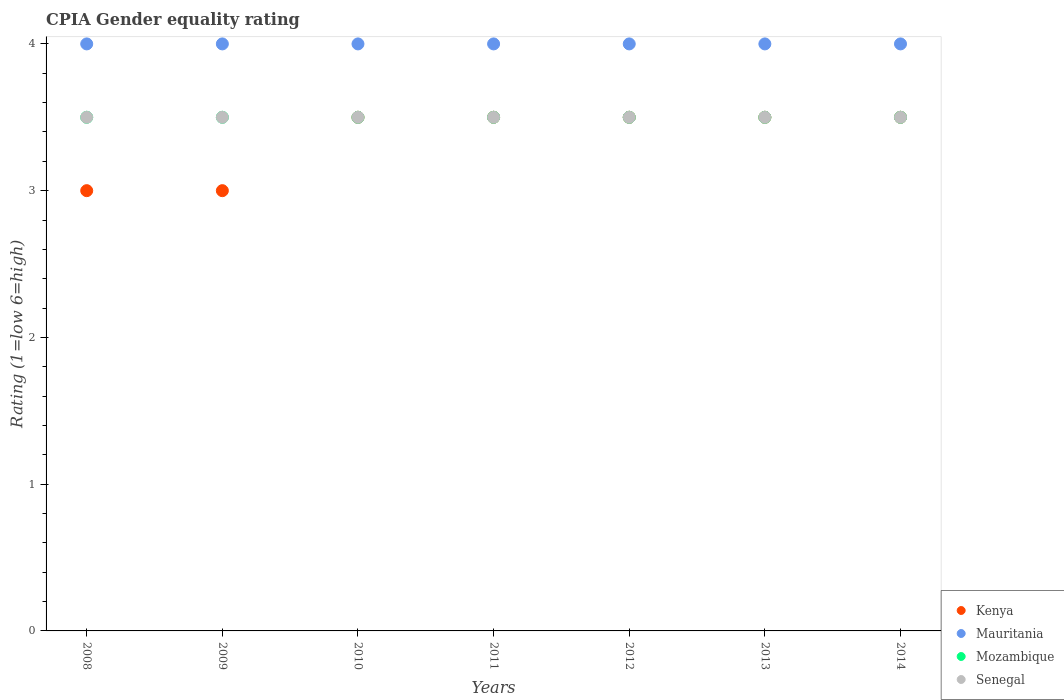How many different coloured dotlines are there?
Your answer should be compact. 4. Is the number of dotlines equal to the number of legend labels?
Offer a very short reply. Yes. What is the CPIA rating in Senegal in 2013?
Give a very brief answer. 3.5. Across all years, what is the minimum CPIA rating in Mozambique?
Offer a terse response. 3.5. In the year 2011, what is the difference between the CPIA rating in Mauritania and CPIA rating in Mozambique?
Offer a terse response. 0.5. In how many years, is the CPIA rating in Senegal greater than 0.2?
Offer a terse response. 7. Is the difference between the CPIA rating in Mauritania in 2010 and 2013 greater than the difference between the CPIA rating in Mozambique in 2010 and 2013?
Give a very brief answer. No. What is the difference between the highest and the lowest CPIA rating in Kenya?
Your answer should be very brief. 0.5. In how many years, is the CPIA rating in Mauritania greater than the average CPIA rating in Mauritania taken over all years?
Your answer should be compact. 0. Is it the case that in every year, the sum of the CPIA rating in Mozambique and CPIA rating in Senegal  is greater than the sum of CPIA rating in Mauritania and CPIA rating in Kenya?
Your answer should be very brief. No. Is the CPIA rating in Kenya strictly greater than the CPIA rating in Mozambique over the years?
Make the answer very short. No. Is the CPIA rating in Mauritania strictly less than the CPIA rating in Kenya over the years?
Ensure brevity in your answer.  No. How many dotlines are there?
Provide a short and direct response. 4. How many years are there in the graph?
Provide a short and direct response. 7. Does the graph contain any zero values?
Offer a very short reply. No. Where does the legend appear in the graph?
Offer a terse response. Bottom right. How many legend labels are there?
Keep it short and to the point. 4. How are the legend labels stacked?
Provide a short and direct response. Vertical. What is the title of the graph?
Offer a very short reply. CPIA Gender equality rating. Does "Palau" appear as one of the legend labels in the graph?
Ensure brevity in your answer.  No. What is the label or title of the X-axis?
Offer a terse response. Years. What is the label or title of the Y-axis?
Your response must be concise. Rating (1=low 6=high). What is the Rating (1=low 6=high) of Kenya in 2008?
Keep it short and to the point. 3. What is the Rating (1=low 6=high) of Senegal in 2008?
Make the answer very short. 3.5. What is the Rating (1=low 6=high) in Mauritania in 2009?
Offer a very short reply. 4. What is the Rating (1=low 6=high) in Mozambique in 2009?
Your answer should be very brief. 3.5. What is the Rating (1=low 6=high) of Senegal in 2009?
Provide a succinct answer. 3.5. What is the Rating (1=low 6=high) of Mauritania in 2010?
Keep it short and to the point. 4. What is the Rating (1=low 6=high) of Mozambique in 2010?
Ensure brevity in your answer.  3.5. What is the Rating (1=low 6=high) in Mauritania in 2011?
Your response must be concise. 4. What is the Rating (1=low 6=high) of Mozambique in 2011?
Ensure brevity in your answer.  3.5. What is the Rating (1=low 6=high) in Kenya in 2012?
Offer a terse response. 3.5. What is the Rating (1=low 6=high) in Mauritania in 2012?
Give a very brief answer. 4. What is the Rating (1=low 6=high) in Mozambique in 2012?
Your answer should be very brief. 3.5. What is the Rating (1=low 6=high) in Senegal in 2012?
Provide a succinct answer. 3.5. What is the Rating (1=low 6=high) in Mauritania in 2013?
Your answer should be compact. 4. What is the Rating (1=low 6=high) of Mauritania in 2014?
Provide a short and direct response. 4. What is the Rating (1=low 6=high) of Mozambique in 2014?
Provide a short and direct response. 3.5. What is the Rating (1=low 6=high) of Senegal in 2014?
Offer a terse response. 3.5. Across all years, what is the maximum Rating (1=low 6=high) of Kenya?
Provide a succinct answer. 3.5. Across all years, what is the maximum Rating (1=low 6=high) in Mauritania?
Keep it short and to the point. 4. Across all years, what is the minimum Rating (1=low 6=high) in Mauritania?
Your response must be concise. 4. Across all years, what is the minimum Rating (1=low 6=high) of Mozambique?
Your answer should be very brief. 3.5. What is the total Rating (1=low 6=high) of Kenya in the graph?
Ensure brevity in your answer.  23.5. What is the total Rating (1=low 6=high) of Mauritania in the graph?
Make the answer very short. 28. What is the total Rating (1=low 6=high) of Mozambique in the graph?
Keep it short and to the point. 24.5. What is the difference between the Rating (1=low 6=high) of Kenya in 2008 and that in 2009?
Your response must be concise. 0. What is the difference between the Rating (1=low 6=high) of Mauritania in 2008 and that in 2009?
Offer a very short reply. 0. What is the difference between the Rating (1=low 6=high) of Senegal in 2008 and that in 2009?
Make the answer very short. 0. What is the difference between the Rating (1=low 6=high) of Kenya in 2008 and that in 2010?
Give a very brief answer. -0.5. What is the difference between the Rating (1=low 6=high) in Mauritania in 2008 and that in 2010?
Provide a succinct answer. 0. What is the difference between the Rating (1=low 6=high) of Senegal in 2008 and that in 2010?
Offer a terse response. 0. What is the difference between the Rating (1=low 6=high) of Kenya in 2008 and that in 2011?
Your answer should be compact. -0.5. What is the difference between the Rating (1=low 6=high) of Mauritania in 2008 and that in 2011?
Offer a terse response. 0. What is the difference between the Rating (1=low 6=high) of Kenya in 2008 and that in 2012?
Offer a very short reply. -0.5. What is the difference between the Rating (1=low 6=high) in Senegal in 2008 and that in 2012?
Provide a short and direct response. 0. What is the difference between the Rating (1=low 6=high) of Mauritania in 2008 and that in 2013?
Keep it short and to the point. 0. What is the difference between the Rating (1=low 6=high) in Mozambique in 2008 and that in 2013?
Make the answer very short. 0. What is the difference between the Rating (1=low 6=high) in Kenya in 2008 and that in 2014?
Your answer should be compact. -0.5. What is the difference between the Rating (1=low 6=high) of Mauritania in 2008 and that in 2014?
Give a very brief answer. 0. What is the difference between the Rating (1=low 6=high) of Mozambique in 2008 and that in 2014?
Provide a short and direct response. 0. What is the difference between the Rating (1=low 6=high) in Senegal in 2008 and that in 2014?
Keep it short and to the point. 0. What is the difference between the Rating (1=low 6=high) of Kenya in 2009 and that in 2010?
Your response must be concise. -0.5. What is the difference between the Rating (1=low 6=high) in Mauritania in 2009 and that in 2010?
Provide a succinct answer. 0. What is the difference between the Rating (1=low 6=high) of Kenya in 2009 and that in 2011?
Your response must be concise. -0.5. What is the difference between the Rating (1=low 6=high) in Mozambique in 2009 and that in 2011?
Offer a very short reply. 0. What is the difference between the Rating (1=low 6=high) in Senegal in 2009 and that in 2011?
Your answer should be compact. 0. What is the difference between the Rating (1=low 6=high) of Mauritania in 2009 and that in 2012?
Make the answer very short. 0. What is the difference between the Rating (1=low 6=high) in Mozambique in 2009 and that in 2012?
Give a very brief answer. 0. What is the difference between the Rating (1=low 6=high) in Senegal in 2009 and that in 2012?
Give a very brief answer. 0. What is the difference between the Rating (1=low 6=high) in Mauritania in 2009 and that in 2013?
Offer a terse response. 0. What is the difference between the Rating (1=low 6=high) in Mauritania in 2009 and that in 2014?
Your answer should be compact. 0. What is the difference between the Rating (1=low 6=high) in Senegal in 2009 and that in 2014?
Make the answer very short. 0. What is the difference between the Rating (1=low 6=high) of Kenya in 2010 and that in 2011?
Make the answer very short. 0. What is the difference between the Rating (1=low 6=high) in Mozambique in 2010 and that in 2011?
Provide a short and direct response. 0. What is the difference between the Rating (1=low 6=high) in Mauritania in 2010 and that in 2012?
Make the answer very short. 0. What is the difference between the Rating (1=low 6=high) of Mozambique in 2010 and that in 2012?
Your response must be concise. 0. What is the difference between the Rating (1=low 6=high) in Senegal in 2010 and that in 2012?
Keep it short and to the point. 0. What is the difference between the Rating (1=low 6=high) in Kenya in 2010 and that in 2013?
Offer a terse response. 0. What is the difference between the Rating (1=low 6=high) of Mauritania in 2010 and that in 2013?
Ensure brevity in your answer.  0. What is the difference between the Rating (1=low 6=high) in Mozambique in 2010 and that in 2014?
Provide a succinct answer. 0. What is the difference between the Rating (1=low 6=high) in Mozambique in 2011 and that in 2012?
Ensure brevity in your answer.  0. What is the difference between the Rating (1=low 6=high) in Senegal in 2011 and that in 2012?
Keep it short and to the point. 0. What is the difference between the Rating (1=low 6=high) in Kenya in 2011 and that in 2013?
Make the answer very short. 0. What is the difference between the Rating (1=low 6=high) of Mauritania in 2011 and that in 2014?
Offer a very short reply. 0. What is the difference between the Rating (1=low 6=high) of Senegal in 2011 and that in 2014?
Keep it short and to the point. 0. What is the difference between the Rating (1=low 6=high) in Kenya in 2012 and that in 2013?
Offer a terse response. 0. What is the difference between the Rating (1=low 6=high) of Mauritania in 2012 and that in 2013?
Provide a short and direct response. 0. What is the difference between the Rating (1=low 6=high) in Senegal in 2012 and that in 2014?
Provide a succinct answer. 0. What is the difference between the Rating (1=low 6=high) of Mozambique in 2013 and that in 2014?
Offer a very short reply. 0. What is the difference between the Rating (1=low 6=high) in Senegal in 2013 and that in 2014?
Your answer should be compact. 0. What is the difference between the Rating (1=low 6=high) of Kenya in 2008 and the Rating (1=low 6=high) of Mauritania in 2009?
Your response must be concise. -1. What is the difference between the Rating (1=low 6=high) in Mauritania in 2008 and the Rating (1=low 6=high) in Mozambique in 2009?
Offer a terse response. 0.5. What is the difference between the Rating (1=low 6=high) of Mauritania in 2008 and the Rating (1=low 6=high) of Senegal in 2009?
Offer a terse response. 0.5. What is the difference between the Rating (1=low 6=high) in Kenya in 2008 and the Rating (1=low 6=high) in Mozambique in 2010?
Provide a short and direct response. -0.5. What is the difference between the Rating (1=low 6=high) in Mauritania in 2008 and the Rating (1=low 6=high) in Mozambique in 2010?
Give a very brief answer. 0.5. What is the difference between the Rating (1=low 6=high) of Mauritania in 2008 and the Rating (1=low 6=high) of Senegal in 2010?
Provide a short and direct response. 0.5. What is the difference between the Rating (1=low 6=high) in Mozambique in 2008 and the Rating (1=low 6=high) in Senegal in 2010?
Keep it short and to the point. 0. What is the difference between the Rating (1=low 6=high) in Kenya in 2008 and the Rating (1=low 6=high) in Mauritania in 2011?
Provide a succinct answer. -1. What is the difference between the Rating (1=low 6=high) in Kenya in 2008 and the Rating (1=low 6=high) in Mozambique in 2011?
Your answer should be very brief. -0.5. What is the difference between the Rating (1=low 6=high) of Mozambique in 2008 and the Rating (1=low 6=high) of Senegal in 2011?
Ensure brevity in your answer.  0. What is the difference between the Rating (1=low 6=high) of Kenya in 2008 and the Rating (1=low 6=high) of Mauritania in 2012?
Offer a very short reply. -1. What is the difference between the Rating (1=low 6=high) of Kenya in 2008 and the Rating (1=low 6=high) of Mozambique in 2012?
Provide a succinct answer. -0.5. What is the difference between the Rating (1=low 6=high) in Mauritania in 2008 and the Rating (1=low 6=high) in Mozambique in 2012?
Your response must be concise. 0.5. What is the difference between the Rating (1=low 6=high) of Mauritania in 2008 and the Rating (1=low 6=high) of Mozambique in 2013?
Ensure brevity in your answer.  0.5. What is the difference between the Rating (1=low 6=high) in Kenya in 2008 and the Rating (1=low 6=high) in Mozambique in 2014?
Keep it short and to the point. -0.5. What is the difference between the Rating (1=low 6=high) in Kenya in 2008 and the Rating (1=low 6=high) in Senegal in 2014?
Make the answer very short. -0.5. What is the difference between the Rating (1=low 6=high) in Mauritania in 2008 and the Rating (1=low 6=high) in Senegal in 2014?
Make the answer very short. 0.5. What is the difference between the Rating (1=low 6=high) in Mozambique in 2008 and the Rating (1=low 6=high) in Senegal in 2014?
Your answer should be compact. 0. What is the difference between the Rating (1=low 6=high) in Kenya in 2009 and the Rating (1=low 6=high) in Mauritania in 2010?
Ensure brevity in your answer.  -1. What is the difference between the Rating (1=low 6=high) in Mauritania in 2009 and the Rating (1=low 6=high) in Mozambique in 2010?
Give a very brief answer. 0.5. What is the difference between the Rating (1=low 6=high) of Kenya in 2009 and the Rating (1=low 6=high) of Mauritania in 2011?
Your answer should be very brief. -1. What is the difference between the Rating (1=low 6=high) in Kenya in 2009 and the Rating (1=low 6=high) in Senegal in 2011?
Keep it short and to the point. -0.5. What is the difference between the Rating (1=low 6=high) in Mauritania in 2009 and the Rating (1=low 6=high) in Senegal in 2011?
Your answer should be compact. 0.5. What is the difference between the Rating (1=low 6=high) in Mozambique in 2009 and the Rating (1=low 6=high) in Senegal in 2011?
Your answer should be very brief. 0. What is the difference between the Rating (1=low 6=high) of Kenya in 2009 and the Rating (1=low 6=high) of Mozambique in 2012?
Your answer should be very brief. -0.5. What is the difference between the Rating (1=low 6=high) of Kenya in 2009 and the Rating (1=low 6=high) of Senegal in 2012?
Your response must be concise. -0.5. What is the difference between the Rating (1=low 6=high) of Mauritania in 2009 and the Rating (1=low 6=high) of Mozambique in 2012?
Your response must be concise. 0.5. What is the difference between the Rating (1=low 6=high) of Mozambique in 2009 and the Rating (1=low 6=high) of Senegal in 2012?
Your response must be concise. 0. What is the difference between the Rating (1=low 6=high) of Kenya in 2009 and the Rating (1=low 6=high) of Mauritania in 2013?
Your answer should be compact. -1. What is the difference between the Rating (1=low 6=high) in Kenya in 2009 and the Rating (1=low 6=high) in Mozambique in 2013?
Your answer should be compact. -0.5. What is the difference between the Rating (1=low 6=high) of Mauritania in 2009 and the Rating (1=low 6=high) of Mozambique in 2013?
Make the answer very short. 0.5. What is the difference between the Rating (1=low 6=high) of Mauritania in 2009 and the Rating (1=low 6=high) of Senegal in 2013?
Your answer should be very brief. 0.5. What is the difference between the Rating (1=low 6=high) in Mozambique in 2009 and the Rating (1=low 6=high) in Senegal in 2013?
Your answer should be very brief. 0. What is the difference between the Rating (1=low 6=high) of Mozambique in 2009 and the Rating (1=low 6=high) of Senegal in 2014?
Make the answer very short. 0. What is the difference between the Rating (1=low 6=high) of Kenya in 2010 and the Rating (1=low 6=high) of Mauritania in 2011?
Offer a terse response. -0.5. What is the difference between the Rating (1=low 6=high) in Kenya in 2010 and the Rating (1=low 6=high) in Senegal in 2011?
Provide a short and direct response. 0. What is the difference between the Rating (1=low 6=high) of Mauritania in 2010 and the Rating (1=low 6=high) of Senegal in 2011?
Offer a very short reply. 0.5. What is the difference between the Rating (1=low 6=high) in Kenya in 2010 and the Rating (1=low 6=high) in Mauritania in 2012?
Your response must be concise. -0.5. What is the difference between the Rating (1=low 6=high) in Kenya in 2010 and the Rating (1=low 6=high) in Mozambique in 2012?
Provide a succinct answer. 0. What is the difference between the Rating (1=low 6=high) of Kenya in 2010 and the Rating (1=low 6=high) of Senegal in 2012?
Make the answer very short. 0. What is the difference between the Rating (1=low 6=high) in Mauritania in 2010 and the Rating (1=low 6=high) in Mozambique in 2012?
Offer a very short reply. 0.5. What is the difference between the Rating (1=low 6=high) of Mauritania in 2010 and the Rating (1=low 6=high) of Senegal in 2012?
Give a very brief answer. 0.5. What is the difference between the Rating (1=low 6=high) of Mozambique in 2010 and the Rating (1=low 6=high) of Senegal in 2012?
Your response must be concise. 0. What is the difference between the Rating (1=low 6=high) of Kenya in 2010 and the Rating (1=low 6=high) of Mauritania in 2013?
Provide a succinct answer. -0.5. What is the difference between the Rating (1=low 6=high) of Kenya in 2010 and the Rating (1=low 6=high) of Mozambique in 2013?
Give a very brief answer. 0. What is the difference between the Rating (1=low 6=high) in Mauritania in 2010 and the Rating (1=low 6=high) in Senegal in 2013?
Give a very brief answer. 0.5. What is the difference between the Rating (1=low 6=high) of Mozambique in 2010 and the Rating (1=low 6=high) of Senegal in 2013?
Keep it short and to the point. 0. What is the difference between the Rating (1=low 6=high) in Kenya in 2010 and the Rating (1=low 6=high) in Mozambique in 2014?
Give a very brief answer. 0. What is the difference between the Rating (1=low 6=high) of Mauritania in 2010 and the Rating (1=low 6=high) of Mozambique in 2014?
Your answer should be very brief. 0.5. What is the difference between the Rating (1=low 6=high) in Mauritania in 2010 and the Rating (1=low 6=high) in Senegal in 2014?
Offer a very short reply. 0.5. What is the difference between the Rating (1=low 6=high) in Mozambique in 2010 and the Rating (1=low 6=high) in Senegal in 2014?
Your answer should be very brief. 0. What is the difference between the Rating (1=low 6=high) in Kenya in 2011 and the Rating (1=low 6=high) in Mozambique in 2012?
Provide a short and direct response. 0. What is the difference between the Rating (1=low 6=high) of Kenya in 2011 and the Rating (1=low 6=high) of Senegal in 2012?
Keep it short and to the point. 0. What is the difference between the Rating (1=low 6=high) of Kenya in 2011 and the Rating (1=low 6=high) of Mauritania in 2013?
Your answer should be compact. -0.5. What is the difference between the Rating (1=low 6=high) of Kenya in 2011 and the Rating (1=low 6=high) of Senegal in 2013?
Provide a succinct answer. 0. What is the difference between the Rating (1=low 6=high) of Kenya in 2011 and the Rating (1=low 6=high) of Mozambique in 2014?
Keep it short and to the point. 0. What is the difference between the Rating (1=low 6=high) in Mauritania in 2011 and the Rating (1=low 6=high) in Mozambique in 2014?
Provide a short and direct response. 0.5. What is the difference between the Rating (1=low 6=high) in Mozambique in 2011 and the Rating (1=low 6=high) in Senegal in 2014?
Give a very brief answer. 0. What is the difference between the Rating (1=low 6=high) in Kenya in 2012 and the Rating (1=low 6=high) in Mozambique in 2013?
Keep it short and to the point. 0. What is the difference between the Rating (1=low 6=high) of Mozambique in 2012 and the Rating (1=low 6=high) of Senegal in 2013?
Your answer should be compact. 0. What is the difference between the Rating (1=low 6=high) in Mauritania in 2012 and the Rating (1=low 6=high) in Senegal in 2014?
Give a very brief answer. 0.5. What is the difference between the Rating (1=low 6=high) in Kenya in 2013 and the Rating (1=low 6=high) in Mauritania in 2014?
Make the answer very short. -0.5. What is the difference between the Rating (1=low 6=high) in Kenya in 2013 and the Rating (1=low 6=high) in Mozambique in 2014?
Your response must be concise. 0. What is the difference between the Rating (1=low 6=high) in Kenya in 2013 and the Rating (1=low 6=high) in Senegal in 2014?
Your answer should be very brief. 0. What is the average Rating (1=low 6=high) in Kenya per year?
Ensure brevity in your answer.  3.36. What is the average Rating (1=low 6=high) of Mozambique per year?
Provide a succinct answer. 3.5. In the year 2008, what is the difference between the Rating (1=low 6=high) of Kenya and Rating (1=low 6=high) of Mauritania?
Ensure brevity in your answer.  -1. In the year 2008, what is the difference between the Rating (1=low 6=high) of Kenya and Rating (1=low 6=high) of Mozambique?
Provide a succinct answer. -0.5. In the year 2008, what is the difference between the Rating (1=low 6=high) of Mauritania and Rating (1=low 6=high) of Senegal?
Provide a succinct answer. 0.5. In the year 2009, what is the difference between the Rating (1=low 6=high) of Mozambique and Rating (1=low 6=high) of Senegal?
Make the answer very short. 0. In the year 2010, what is the difference between the Rating (1=low 6=high) of Kenya and Rating (1=low 6=high) of Mauritania?
Keep it short and to the point. -0.5. In the year 2010, what is the difference between the Rating (1=low 6=high) of Kenya and Rating (1=low 6=high) of Mozambique?
Ensure brevity in your answer.  0. In the year 2010, what is the difference between the Rating (1=low 6=high) in Mauritania and Rating (1=low 6=high) in Mozambique?
Your answer should be very brief. 0.5. In the year 2010, what is the difference between the Rating (1=low 6=high) of Mauritania and Rating (1=low 6=high) of Senegal?
Your response must be concise. 0.5. In the year 2010, what is the difference between the Rating (1=low 6=high) of Mozambique and Rating (1=low 6=high) of Senegal?
Make the answer very short. 0. In the year 2011, what is the difference between the Rating (1=low 6=high) of Kenya and Rating (1=low 6=high) of Mauritania?
Make the answer very short. -0.5. In the year 2011, what is the difference between the Rating (1=low 6=high) of Kenya and Rating (1=low 6=high) of Senegal?
Ensure brevity in your answer.  0. In the year 2011, what is the difference between the Rating (1=low 6=high) of Mauritania and Rating (1=low 6=high) of Mozambique?
Your answer should be compact. 0.5. In the year 2011, what is the difference between the Rating (1=low 6=high) in Mozambique and Rating (1=low 6=high) in Senegal?
Provide a succinct answer. 0. In the year 2012, what is the difference between the Rating (1=low 6=high) in Kenya and Rating (1=low 6=high) in Mauritania?
Your answer should be compact. -0.5. In the year 2012, what is the difference between the Rating (1=low 6=high) of Mauritania and Rating (1=low 6=high) of Senegal?
Keep it short and to the point. 0.5. In the year 2013, what is the difference between the Rating (1=low 6=high) in Kenya and Rating (1=low 6=high) in Mauritania?
Your answer should be very brief. -0.5. In the year 2013, what is the difference between the Rating (1=low 6=high) in Kenya and Rating (1=low 6=high) in Mozambique?
Ensure brevity in your answer.  0. In the year 2013, what is the difference between the Rating (1=low 6=high) of Mauritania and Rating (1=low 6=high) of Mozambique?
Offer a very short reply. 0.5. In the year 2014, what is the difference between the Rating (1=low 6=high) in Kenya and Rating (1=low 6=high) in Mozambique?
Your answer should be compact. 0. What is the ratio of the Rating (1=low 6=high) of Kenya in 2008 to that in 2009?
Your answer should be very brief. 1. What is the ratio of the Rating (1=low 6=high) in Senegal in 2008 to that in 2009?
Your answer should be very brief. 1. What is the ratio of the Rating (1=low 6=high) in Kenya in 2008 to that in 2010?
Offer a terse response. 0.86. What is the ratio of the Rating (1=low 6=high) of Senegal in 2008 to that in 2010?
Your response must be concise. 1. What is the ratio of the Rating (1=low 6=high) in Kenya in 2008 to that in 2011?
Keep it short and to the point. 0.86. What is the ratio of the Rating (1=low 6=high) of Mozambique in 2008 to that in 2011?
Your answer should be very brief. 1. What is the ratio of the Rating (1=low 6=high) in Senegal in 2008 to that in 2011?
Ensure brevity in your answer.  1. What is the ratio of the Rating (1=low 6=high) in Senegal in 2008 to that in 2012?
Provide a succinct answer. 1. What is the ratio of the Rating (1=low 6=high) in Mauritania in 2008 to that in 2013?
Keep it short and to the point. 1. What is the ratio of the Rating (1=low 6=high) in Mozambique in 2008 to that in 2013?
Provide a short and direct response. 1. What is the ratio of the Rating (1=low 6=high) in Senegal in 2008 to that in 2013?
Your response must be concise. 1. What is the ratio of the Rating (1=low 6=high) of Kenya in 2008 to that in 2014?
Your response must be concise. 0.86. What is the ratio of the Rating (1=low 6=high) in Mauritania in 2008 to that in 2014?
Offer a terse response. 1. What is the ratio of the Rating (1=low 6=high) of Mozambique in 2008 to that in 2014?
Give a very brief answer. 1. What is the ratio of the Rating (1=low 6=high) of Senegal in 2009 to that in 2010?
Offer a very short reply. 1. What is the ratio of the Rating (1=low 6=high) in Kenya in 2009 to that in 2012?
Provide a succinct answer. 0.86. What is the ratio of the Rating (1=low 6=high) in Senegal in 2009 to that in 2013?
Provide a short and direct response. 1. What is the ratio of the Rating (1=low 6=high) of Kenya in 2009 to that in 2014?
Make the answer very short. 0.86. What is the ratio of the Rating (1=low 6=high) in Kenya in 2010 to that in 2011?
Ensure brevity in your answer.  1. What is the ratio of the Rating (1=low 6=high) of Mozambique in 2010 to that in 2011?
Ensure brevity in your answer.  1. What is the ratio of the Rating (1=low 6=high) in Mauritania in 2010 to that in 2012?
Keep it short and to the point. 1. What is the ratio of the Rating (1=low 6=high) of Senegal in 2010 to that in 2012?
Your answer should be compact. 1. What is the ratio of the Rating (1=low 6=high) of Mauritania in 2010 to that in 2013?
Your answer should be very brief. 1. What is the ratio of the Rating (1=low 6=high) of Mozambique in 2010 to that in 2013?
Provide a succinct answer. 1. What is the ratio of the Rating (1=low 6=high) of Senegal in 2011 to that in 2012?
Your answer should be very brief. 1. What is the ratio of the Rating (1=low 6=high) in Kenya in 2011 to that in 2013?
Give a very brief answer. 1. What is the ratio of the Rating (1=low 6=high) of Mauritania in 2011 to that in 2013?
Your answer should be very brief. 1. What is the ratio of the Rating (1=low 6=high) in Kenya in 2011 to that in 2014?
Give a very brief answer. 1. What is the ratio of the Rating (1=low 6=high) of Mozambique in 2011 to that in 2014?
Provide a short and direct response. 1. What is the ratio of the Rating (1=low 6=high) in Kenya in 2012 to that in 2013?
Ensure brevity in your answer.  1. What is the ratio of the Rating (1=low 6=high) in Mauritania in 2012 to that in 2013?
Give a very brief answer. 1. What is the ratio of the Rating (1=low 6=high) of Mozambique in 2012 to that in 2013?
Your response must be concise. 1. What is the ratio of the Rating (1=low 6=high) in Kenya in 2012 to that in 2014?
Ensure brevity in your answer.  1. What is the ratio of the Rating (1=low 6=high) in Mauritania in 2012 to that in 2014?
Provide a short and direct response. 1. What is the ratio of the Rating (1=low 6=high) of Kenya in 2013 to that in 2014?
Your response must be concise. 1. What is the ratio of the Rating (1=low 6=high) in Senegal in 2013 to that in 2014?
Keep it short and to the point. 1. What is the difference between the highest and the second highest Rating (1=low 6=high) of Senegal?
Your answer should be compact. 0. What is the difference between the highest and the lowest Rating (1=low 6=high) in Kenya?
Offer a very short reply. 0.5. 